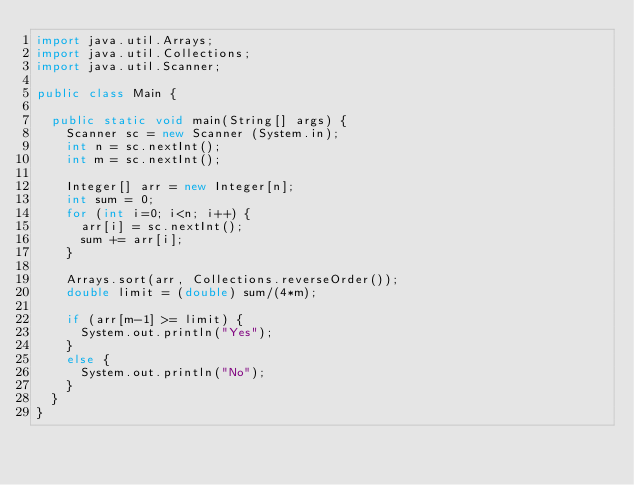Convert code to text. <code><loc_0><loc_0><loc_500><loc_500><_Java_>import java.util.Arrays;
import java.util.Collections;
import java.util.Scanner;

public class Main {

	public static void main(String[] args) {
		Scanner sc = new Scanner (System.in);
		int n = sc.nextInt();
		int m = sc.nextInt();
		
		Integer[] arr = new Integer[n];
		int sum = 0;
		for (int i=0; i<n; i++) {
			arr[i] = sc.nextInt();
			sum += arr[i];
		}
		
		Arrays.sort(arr, Collections.reverseOrder());
		double limit = (double) sum/(4*m);

		if (arr[m-1] >= limit) {
			System.out.println("Yes");
		}
		else {
			System.out.println("No");
		}
	}
}
</code> 